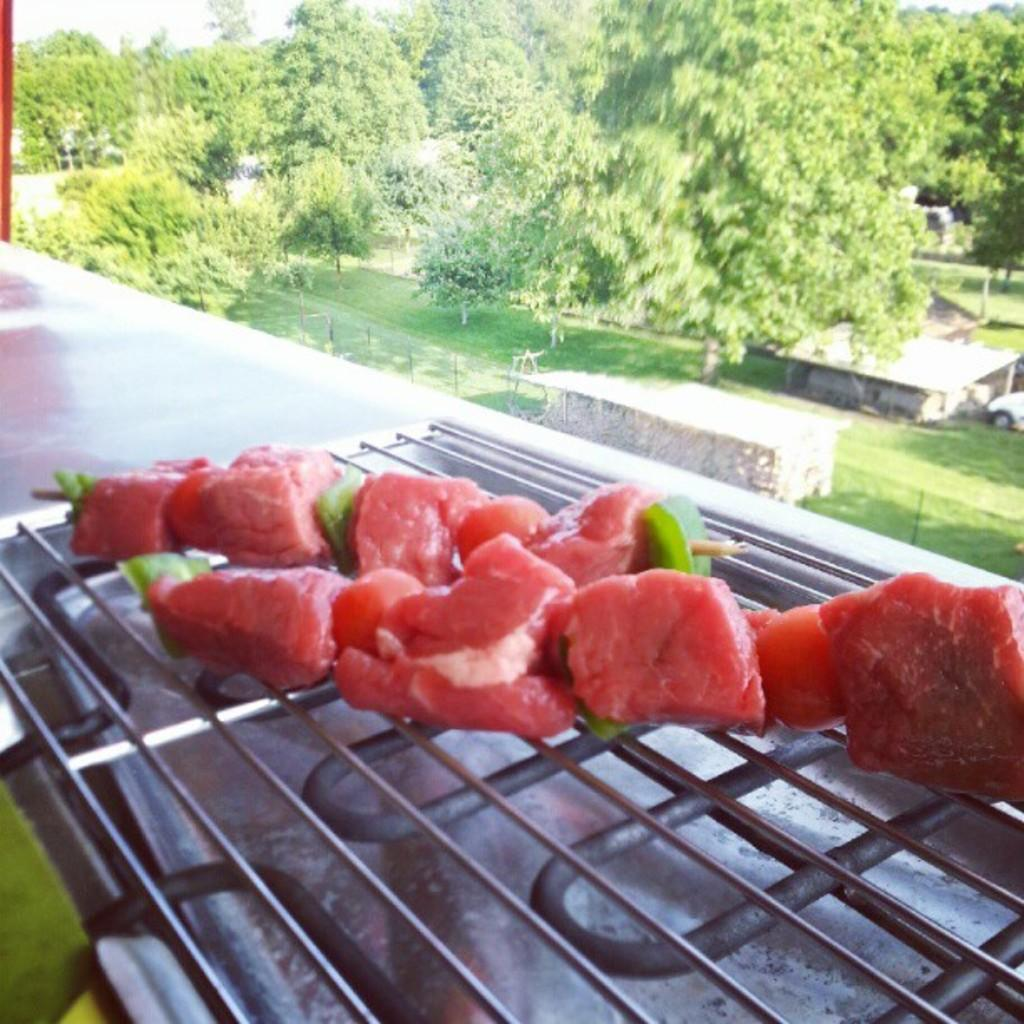What is being cooked on the grills in the image? There is food on grills in the image, but the specific type of food cannot be determined from the facts provided. What can be seen in the background of the image? There are trees and grass in the background of the image. What type of representative is holding the hands of the person in the image? There is no person or representative present in the image; it only shows food on grills and a background with trees and grass. 